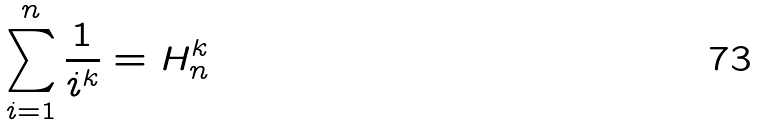<formula> <loc_0><loc_0><loc_500><loc_500>\sum _ { i = 1 } ^ { n } { \frac { 1 } { i ^ { k } } } = H _ { n } ^ { k }</formula> 